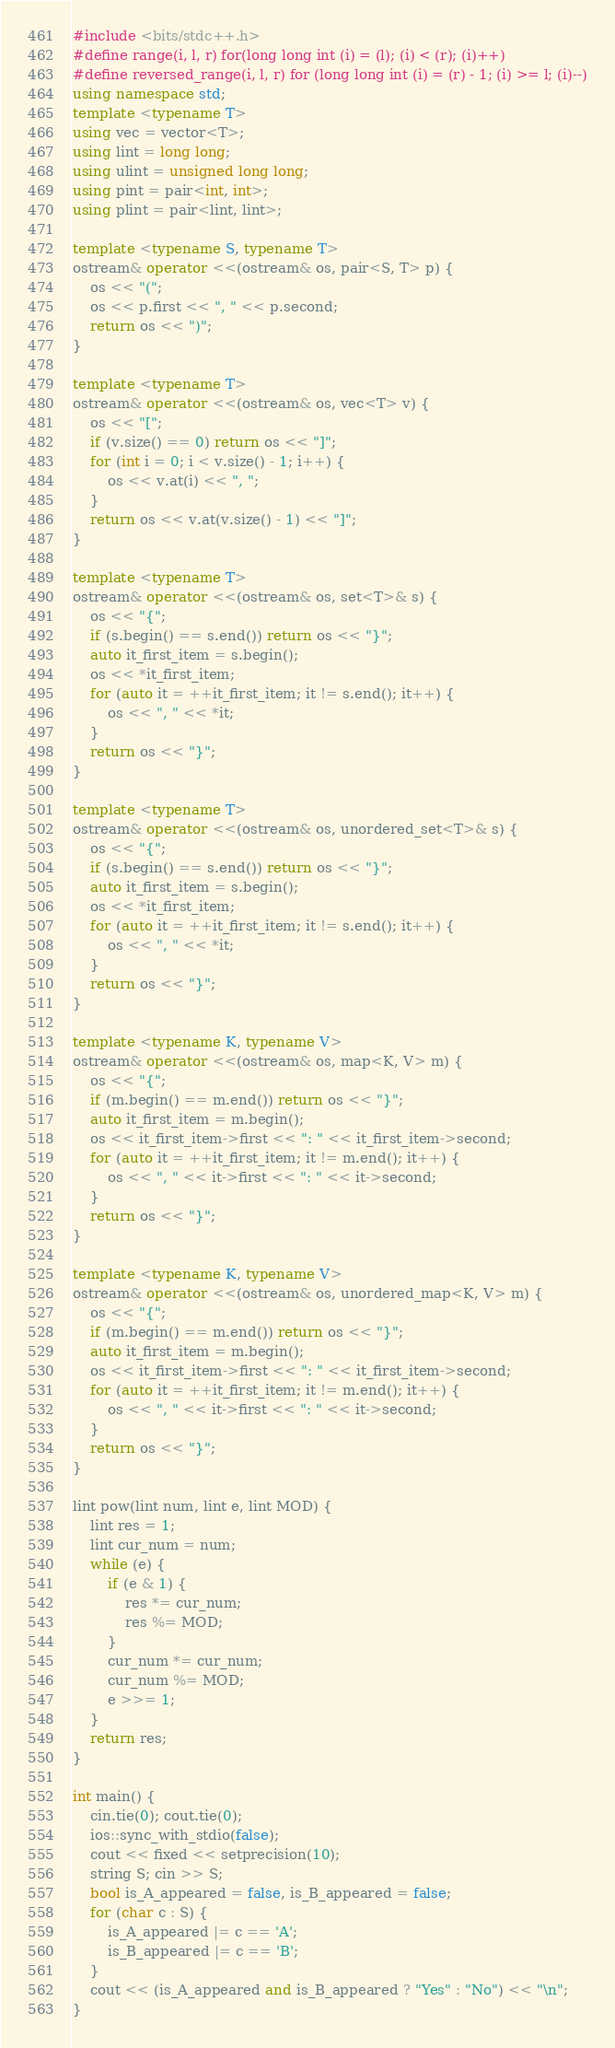<code> <loc_0><loc_0><loc_500><loc_500><_C++_>#include <bits/stdc++.h>
#define range(i, l, r) for(long long int (i) = (l); (i) < (r); (i)++)
#define reversed_range(i, l, r) for (long long int (i) = (r) - 1; (i) >= l; (i)--)
using namespace std;
template <typename T>
using vec = vector<T>;
using lint = long long;
using ulint = unsigned long long;
using pint = pair<int, int>;
using plint = pair<lint, lint>;

template <typename S, typename T>
ostream& operator <<(ostream& os, pair<S, T> p) {
    os << "(";
    os << p.first << ", " << p.second;
    return os << ")";
}

template <typename T>
ostream& operator <<(ostream& os, vec<T> v) {
    os << "[";
    if (v.size() == 0) return os << "]";
    for (int i = 0; i < v.size() - 1; i++) {
        os << v.at(i) << ", ";
    }
    return os << v.at(v.size() - 1) << "]";
}

template <typename T>
ostream& operator <<(ostream& os, set<T>& s) {
    os << "{";
    if (s.begin() == s.end()) return os << "}";
    auto it_first_item = s.begin();
    os << *it_first_item;
    for (auto it = ++it_first_item; it != s.end(); it++) {
        os << ", " << *it;
    }
    return os << "}";
}

template <typename T>
ostream& operator <<(ostream& os, unordered_set<T>& s) {
    os << "{";
    if (s.begin() == s.end()) return os << "}";
    auto it_first_item = s.begin();
    os << *it_first_item;
    for (auto it = ++it_first_item; it != s.end(); it++) {
        os << ", " << *it;
    }
    return os << "}";
}

template <typename K, typename V>
ostream& operator <<(ostream& os, map<K, V> m) {
    os << "{";
    if (m.begin() == m.end()) return os << "}";
    auto it_first_item = m.begin();
    os << it_first_item->first << ": " << it_first_item->second;
    for (auto it = ++it_first_item; it != m.end(); it++) {
        os << ", " << it->first << ": " << it->second;
    }
    return os << "}";
}

template <typename K, typename V>
ostream& operator <<(ostream& os, unordered_map<K, V> m) {
    os << "{";
    if (m.begin() == m.end()) return os << "}";
    auto it_first_item = m.begin();
    os << it_first_item->first << ": " << it_first_item->second;
    for (auto it = ++it_first_item; it != m.end(); it++) {
        os << ", " << it->first << ": " << it->second;
    }
    return os << "}";
}

lint pow(lint num, lint e, lint MOD) {
    lint res = 1;
    lint cur_num = num;
    while (e) {
        if (e & 1) {
            res *= cur_num;
            res %= MOD;
        }
        cur_num *= cur_num;
        cur_num %= MOD;
        e >>= 1;
    }
    return res;
}

int main() {
    cin.tie(0); cout.tie(0);
    ios::sync_with_stdio(false);
    cout << fixed << setprecision(10);
    string S; cin >> S;
    bool is_A_appeared = false, is_B_appeared = false;
    for (char c : S) {
        is_A_appeared |= c == 'A';
        is_B_appeared |= c == 'B';
    }
    cout << (is_A_appeared and is_B_appeared ? "Yes" : "No") << "\n";
}</code> 